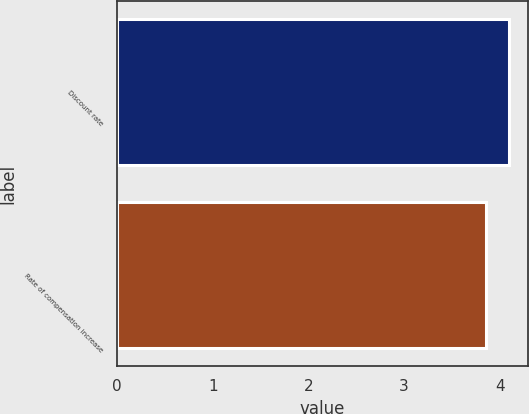Convert chart to OTSL. <chart><loc_0><loc_0><loc_500><loc_500><bar_chart><fcel>Discount rate<fcel>Rate of compensation increase<nl><fcel>4.09<fcel>3.86<nl></chart> 